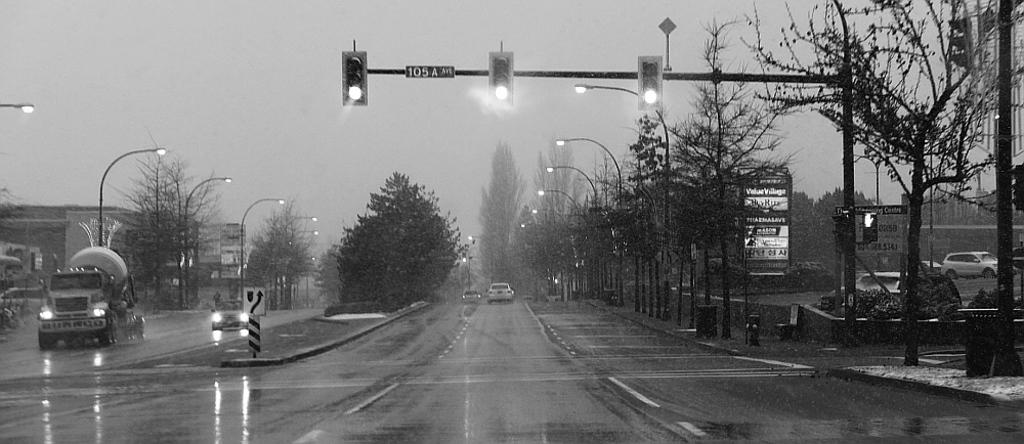What is the main subject of the image? The image depicts a road. What is happening in the image? It is raining in the image. What can be seen in the middle of the road? There are traffic signals in the middle of the road. What type of vegetation is present on either side of the road? There are trees on either side of the road. What is visible at the top of the image? The sky is visible at the top of the image. What type of letter can be seen falling from the sky in the image? There is no letter falling from the sky in the image; it is raining, not snowing or hailing letters. 